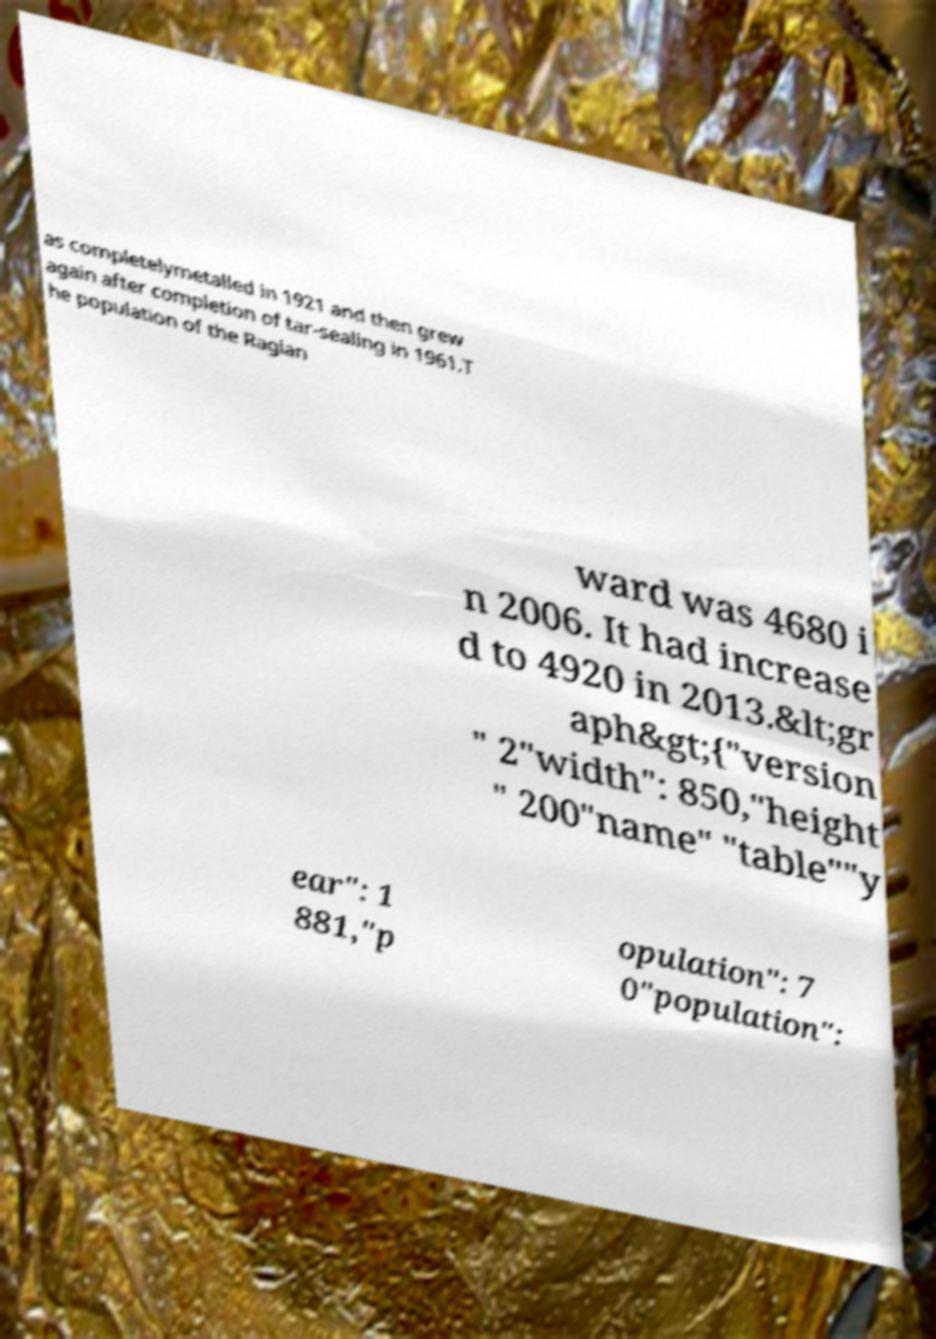There's text embedded in this image that I need extracted. Can you transcribe it verbatim? as completelymetalled in 1921 and then grew again after completion of tar-sealing in 1961.T he population of the Raglan ward was 4680 i n 2006. It had increase d to 4920 in 2013.&lt;gr aph&gt;{"version " 2"width": 850,"height " 200"name" "table""y ear": 1 881,"p opulation": 7 0"population": 